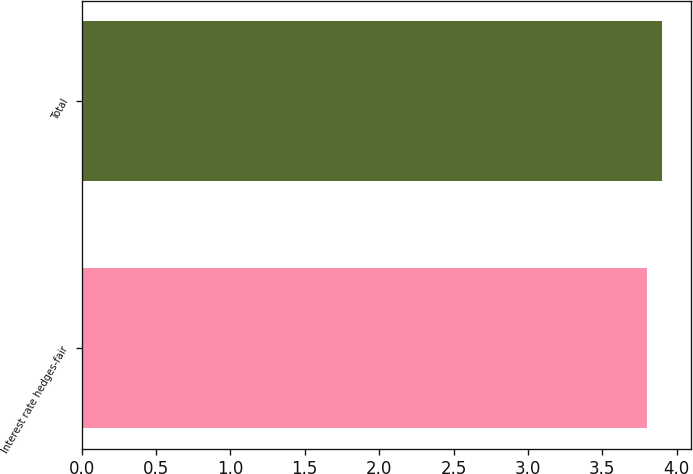<chart> <loc_0><loc_0><loc_500><loc_500><bar_chart><fcel>Interest rate hedges-fair<fcel>Total<nl><fcel>3.8<fcel>3.9<nl></chart> 